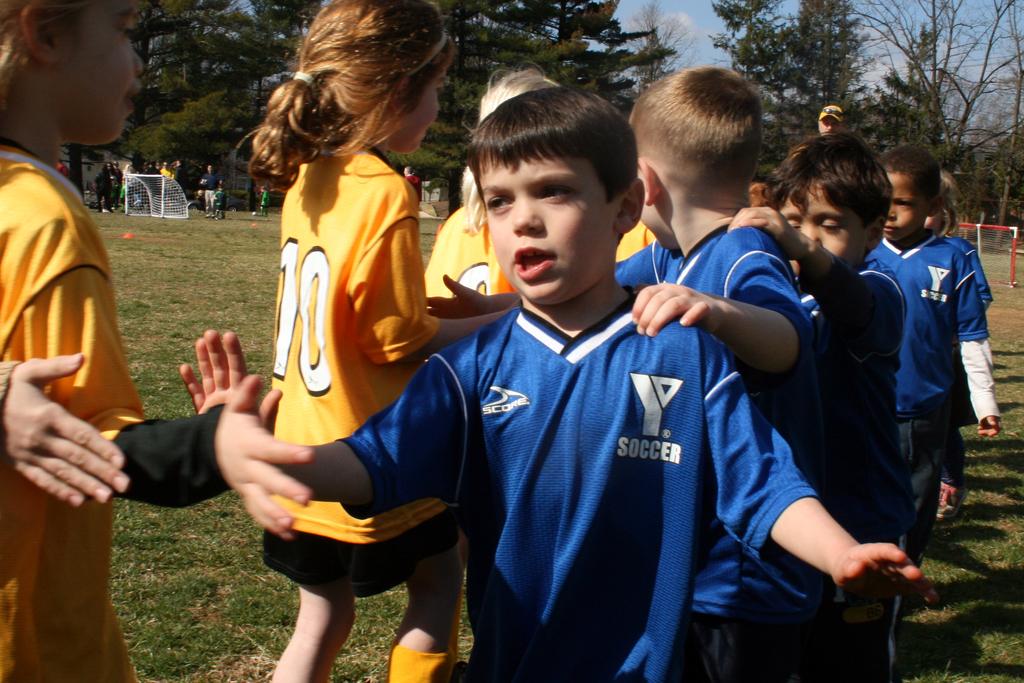What is the team sponsered by?
Make the answer very short. Ymca. 